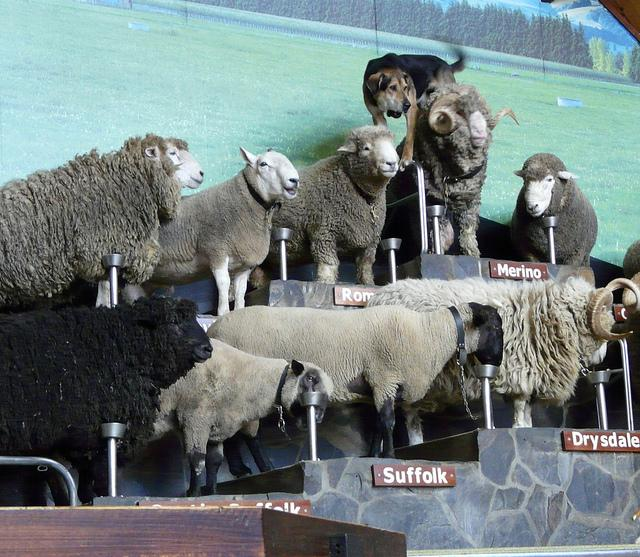Which type of sheep is the highest on the stand? Please explain your reasoning. merino. The merino sheep is highest. 